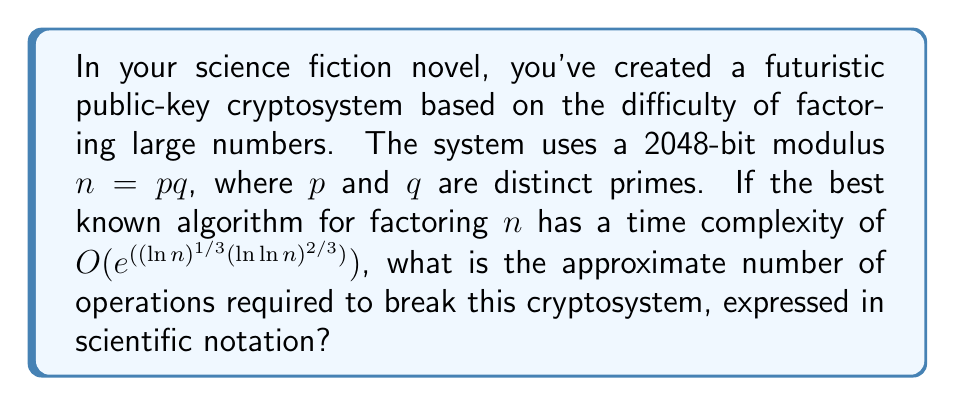Give your solution to this math problem. To solve this problem, we'll follow these steps:

1) First, we need to calculate $\ln n$. Since $n$ is a 2048-bit number, we can express it as $2^{2048}$.
   
   $\ln n = \ln (2^{2048}) = 2048 \ln 2 \approx 1419.97$

2) Next, we calculate $\ln \ln n$:
   
   $\ln \ln n = \ln (1419.97) \approx 7.26$

3) Now, we can compute the exponent in the time complexity formula:

   $$(\ln n)^{1/3} (\ln \ln n)^{2/3} = (1419.97)^{1/3} (7.26)^{2/3} \approx 11.34 \cdot 3.83 \approx 43.43$$

4) The time complexity is $O(e^{43.43})$, so the number of operations is approximately:

   $$e^{43.43} \approx 7.60 \cdot 10^{18}$$

5) Expressing this in scientific notation with two decimal places:

   $$7.60 \cdot 10^{18}$$

This represents the approximate number of operations required to break the cryptosystem.
Answer: $7.60 \cdot 10^{18}$ 